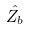<formula> <loc_0><loc_0><loc_500><loc_500>\hat { Z _ { b } }</formula> 